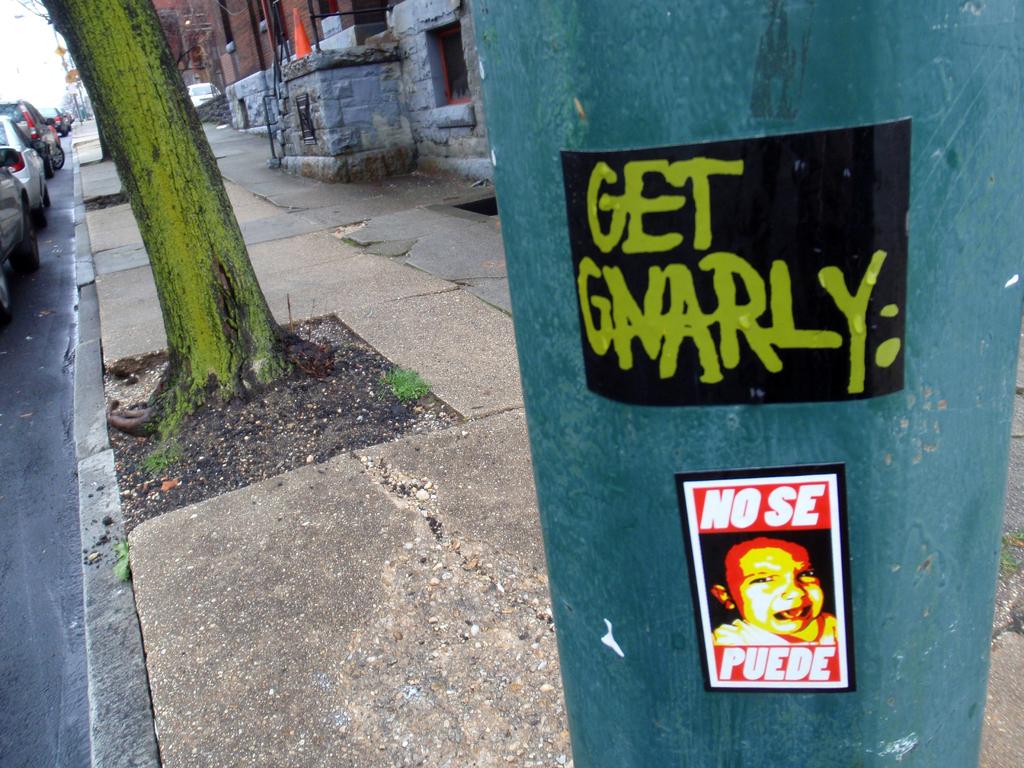What does the sticker say?
Ensure brevity in your answer.  Get gnarly. What color is 'get gnarly' printed in?
Give a very brief answer. Green. 